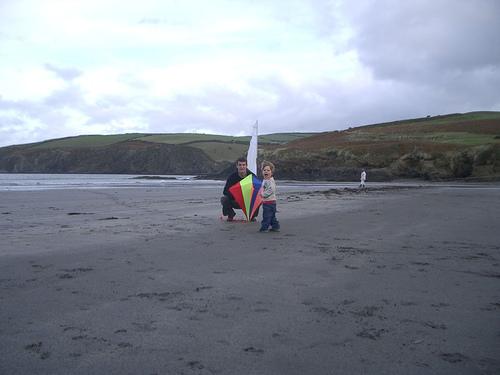How many people do you see?
Be succinct. 2. Are those darker or lighter clouds in the sky?
Concise answer only. Darker. How many people are holding something?
Give a very brief answer. 2. What is the person carrying?
Write a very short answer. Kite. Does it look windy enough for this man to fly his kite successfully?
Quick response, please. Yes. What are the people about to do?
Answer briefly. Fly kite. What is this person carrying?
Be succinct. Kite. Is there a scooter?
Answer briefly. No. How many children?
Answer briefly. 1. 